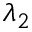<formula> <loc_0><loc_0><loc_500><loc_500>\lambda _ { 2 }</formula> 